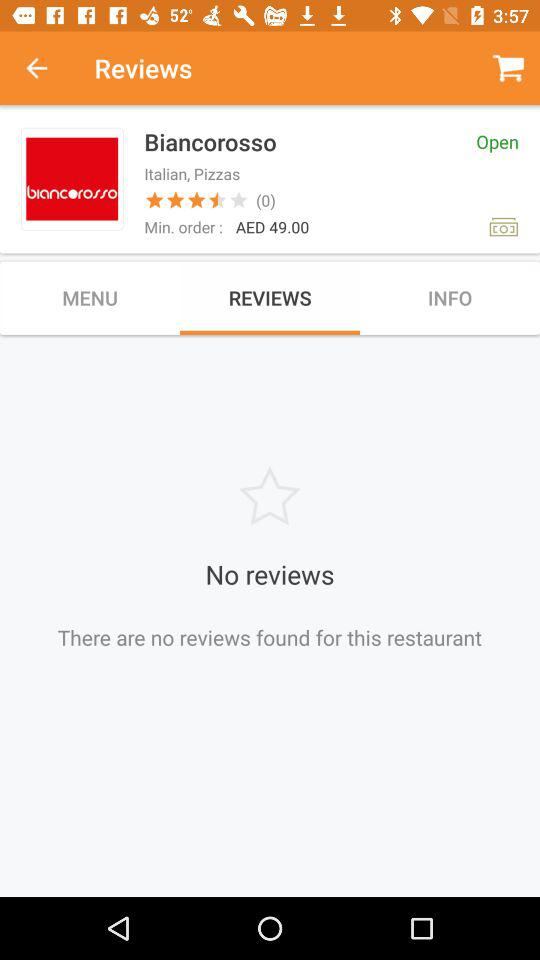What is the price range of Biancorosso?
Answer the question using a single word or phrase. AED 49.00 